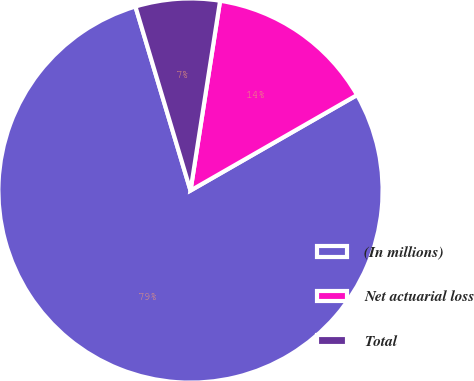Convert chart. <chart><loc_0><loc_0><loc_500><loc_500><pie_chart><fcel>(In millions)<fcel>Net actuarial loss<fcel>Total<nl><fcel>78.66%<fcel>14.25%<fcel>7.09%<nl></chart> 